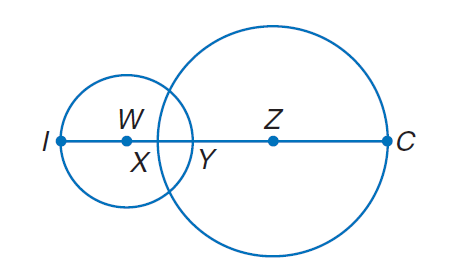Answer the mathemtical geometry problem and directly provide the correct option letter.
Question: Circle W has a radius of 4 units, \odot Z has a radius of 7 units, and X Y = 2. Find I C.
Choices: A: 5 B: 10 C: 15 D: 20 D 